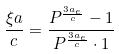Convert formula to latex. <formula><loc_0><loc_0><loc_500><loc_500>\frac { \xi a } { c } = \frac { P ^ { \frac { 3 a _ { e } } { c } } - 1 } { P ^ { \frac { 3 a _ { e } } { c } } \cdot 1 }</formula> 